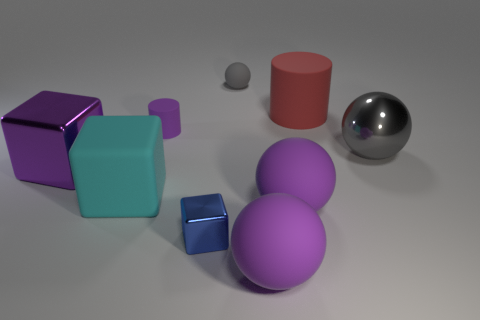The rubber cube has what size?
Offer a very short reply. Large. Do the big purple block and the gray object that is behind the small purple matte cylinder have the same material?
Provide a short and direct response. No. Are there any tiny brown metallic objects of the same shape as the large gray metal thing?
Offer a terse response. No. There is a cyan object that is the same size as the red cylinder; what is its material?
Provide a short and direct response. Rubber. How big is the purple sphere that is behind the tiny block?
Offer a terse response. Large. Does the gray ball that is behind the big gray metal sphere have the same size as the cube on the right side of the cyan object?
Offer a terse response. Yes. How many tiny balls have the same material as the red object?
Keep it short and to the point. 1. What is the color of the large rubber cube?
Keep it short and to the point. Cyan. Are there any purple balls on the left side of the big purple metal cube?
Your answer should be compact. No. Is the small metal thing the same color as the large shiny block?
Keep it short and to the point. No. 